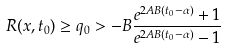<formula> <loc_0><loc_0><loc_500><loc_500>R ( x , t _ { 0 } ) \geq q _ { 0 } > - B \frac { e ^ { 2 A B ( t _ { 0 } - \alpha ) } + 1 } { e ^ { 2 A B ( t _ { 0 } - \alpha ) } - 1 }</formula> 